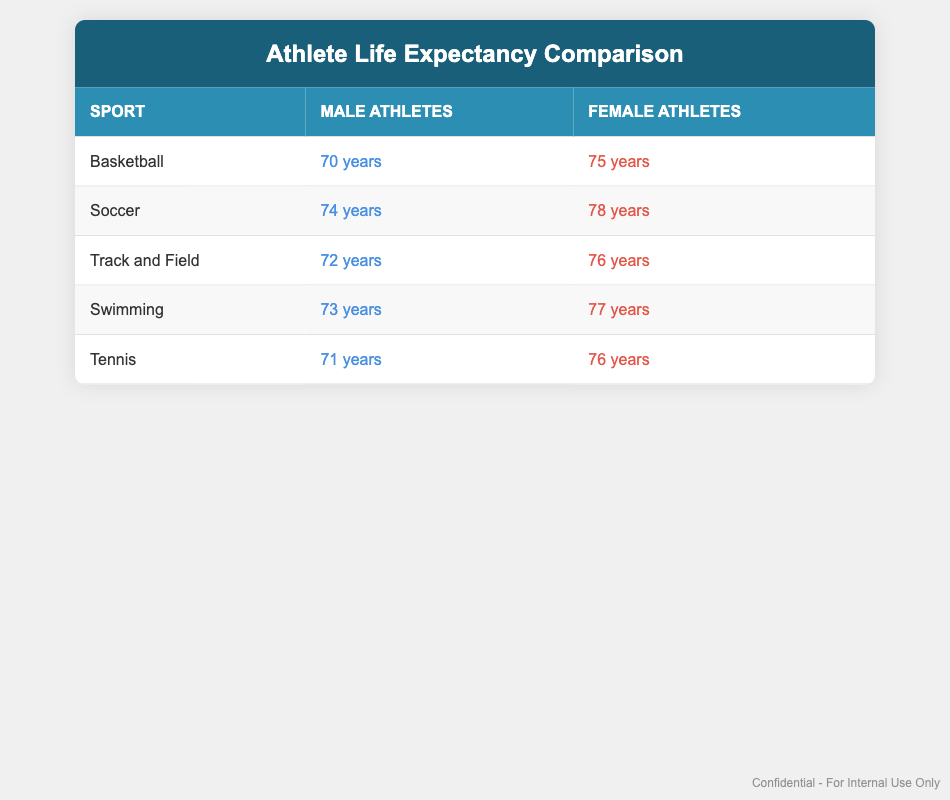What is the life expectancy of male basketball players? The table lists the life expectancy of male basketball players as 70 years. This fact can be directly retrieved from the row corresponding to basketball.
Answer: 70 years What is the life expectancy of female athletes in soccer? According to the table, the life expectancy of female athletes in soccer is 78 years. This value is found in the corresponding row for soccer.
Answer: 78 years What sport has the largest difference in life expectancy between male and female athletes? To find the largest difference, we calculate the difference for each sport: Basketball (75 - 70 = 5), Soccer (78 - 74 = 4), Track and Field (76 - 72 = 4), Swimming (77 - 73 = 4), and Tennis (76 - 71 = 5). The maximum difference is 5 years in both Basketball and Tennis.
Answer: Basketball and Tennis Is the life expectancy of male track and field athletes greater than that of male tennis players? The life expectancy of male track and field athletes is 72 years, while that of male tennis players is 71 years. Therefore, 72 years is greater than 71 years, making the statement true.
Answer: Yes What is the average life expectancy of female athletes across all listed sports? To calculate the average, we sum the life expectancies: 75 (Basketball) + 78 (Soccer) + 76 (Track and Field) + 77 (Swimming) + 76 (Tennis) = 382. There are 5 data points, so the average is 382/5 = 76.4 years.
Answer: 76.4 years How many sports have male athletes with a life expectancy greater than 72 years? Looking at the data, the sports with male athletes having a life expectancy greater than 72 years are Soccer (74), Swimming (73), and Track and Field (72). Therefore, there are three sports that meet this criterion.
Answer: Three Are female athletes generally expected to live longer than male athletes across all sports listed in the table? By comparing the life expectancies in each row, we see that female athletes have higher life expectancy values than male athletes in all cases: 75 vs. 70 (Basketball), 78 vs. 74 (Soccer), etc. Thus, it can be concluded that female athletes generally have a longer lifespan.
Answer: Yes What is the life expectancy of male and female athletes in swimming? The table shows that male athletes in swimming have a life expectancy of 73 years, whereas female athletes have a life expectancy of 77 years. This information is located directly in the row for swimming.
Answer: Male: 73 years, Female: 77 years 